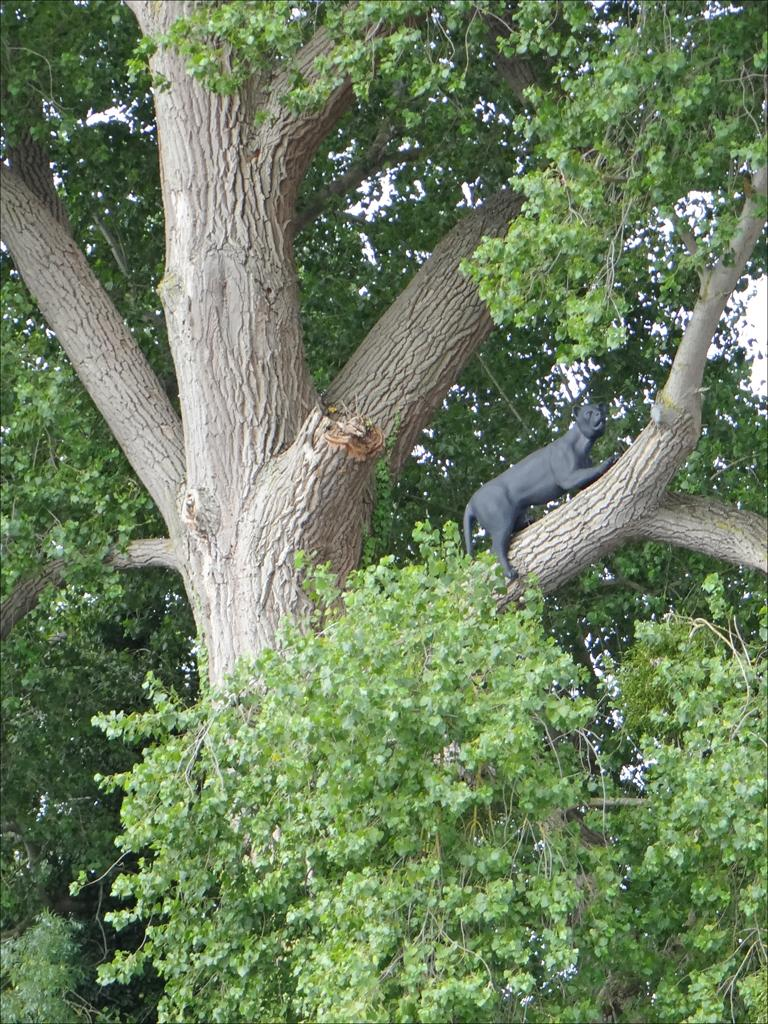What type of object is present in the image that is not a natural part of the environment? There is an artificial animal in the image. Where is the artificial animal located in the image? The artificial animal is lying on a tree branch. What type of natural object is present in the image? There is a tree in the image. What is visible at the top of the image? The sky is visible at the top of the image. How many dinosaurs can be seen in the image? There are no dinosaurs present in the image. What type of bikes are visible in the image? There are no bikes present in the image. 